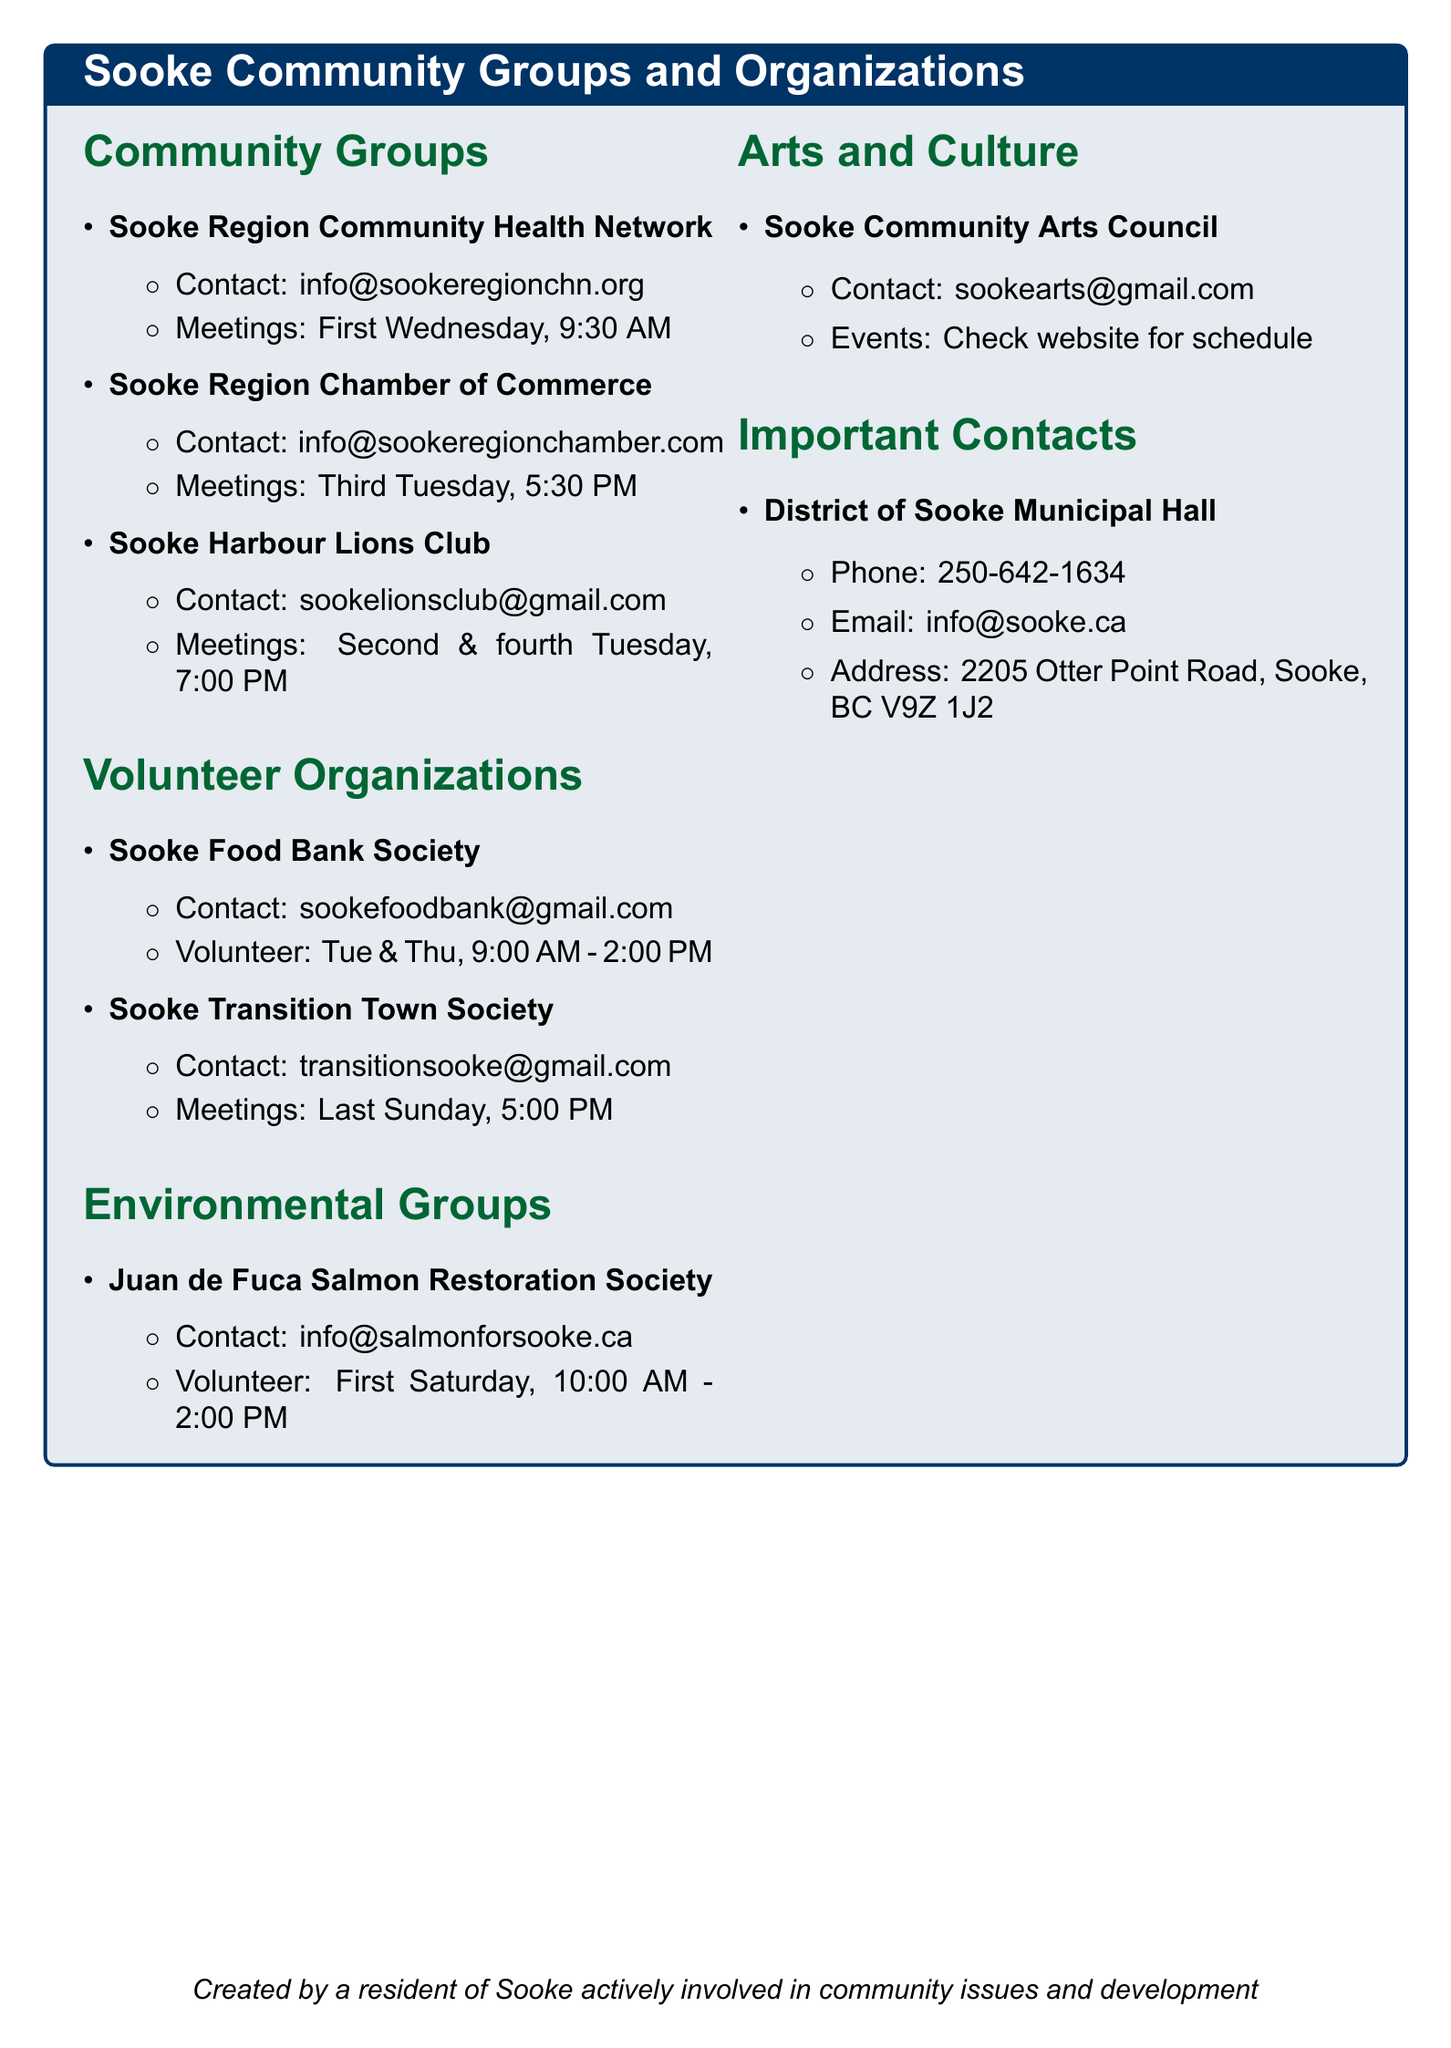What is the contact email for the Sooke Region Chamber of Commerce? The email is specified in the document as the contact for the Sooke Region Chamber of Commerce.
Answer: info@sookeregionchamber.com When does the Sooke Transition Town Society hold its meetings? The document outlines that their meetings occur on the last Sunday of each month.
Answer: Last Sunday, 5:00 PM What day of the week does the Sooke Food Bank Society offer volunteer opportunities? The document mentions that volunteer opportunities are available on Tuesdays and Thursdays.
Answer: Tuesdays and Thursdays How often do meetings occur for the Sooke Harbour Lions Club? The document states that the Sooke Harbour Lions Club meets twice a month.
Answer: Second and fourth Tuesday What is the address of the District of Sooke Municipal Hall? The address is listed as a specific address for contact in the document.
Answer: 2205 Otter Point Road, Sooke, BC V9Z 1J2 On which day and time are stream clean-up events organized by the Juan de Fuca Salmon Restoration Society? The document states that these events occur on the first Saturday of each month.
Answer: First Saturday, 10:00 AM - 2:00 PM What type of events does the Sooke Community Arts Council host? The document indicates that the Sooke Community Arts Council hosts art shows and workshops.
Answer: Art shows and workshops What is the contact email for volunteering with the Sooke Food Bank Society? The document provides the email for the Sooke Food Bank Society, indicating how to contact them for volunteering.
Answer: sookefoodbank@gmail.com 